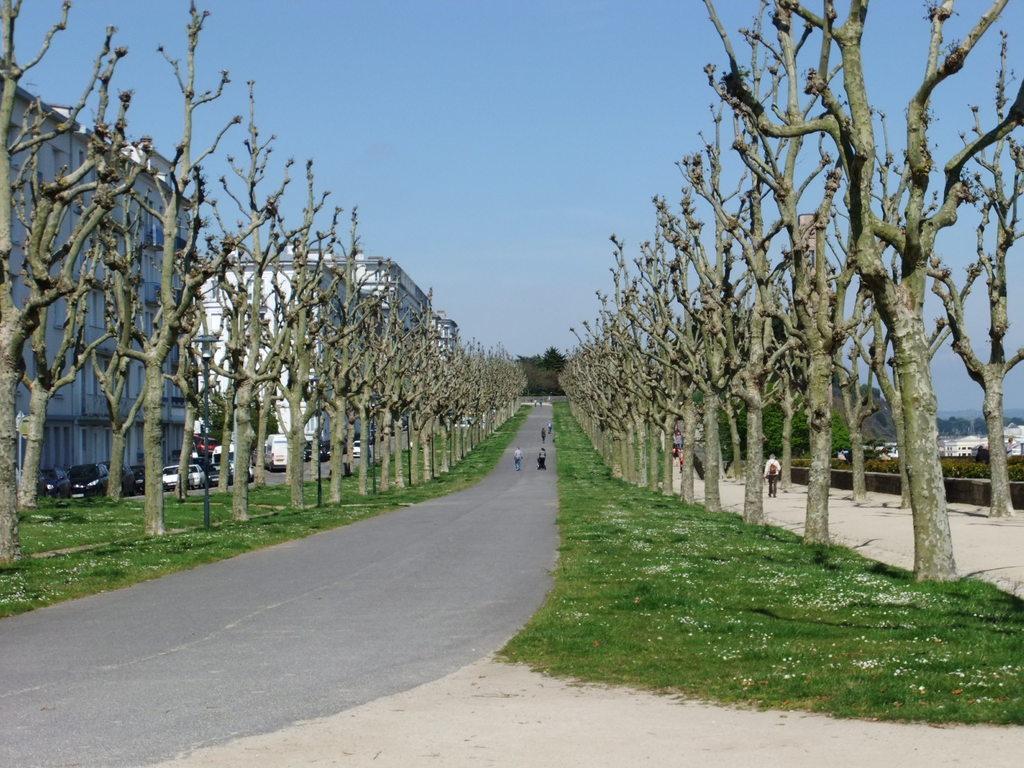Can you describe this image briefly? This image is clicked outside. There are buildings on the left side. There are trees in the middle. There are some people walking in the middle. There are cars on the left side. There is sky at the top. 